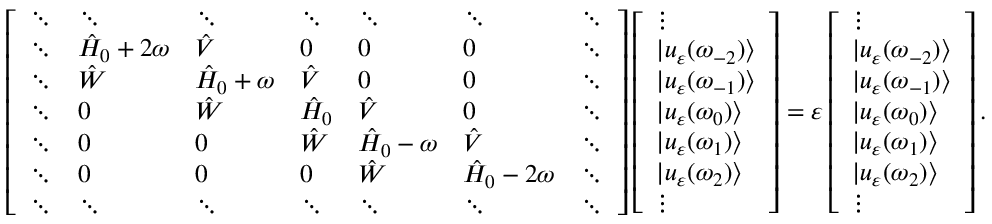<formula> <loc_0><loc_0><loc_500><loc_500>\left [ \begin{array} { l l l l l l l } { \ddots } & { \ddots } & { \ddots } & { \ddots } & { \ddots } & { \ddots } & { \ddots } \\ { \ddots } & { \hat { H } _ { 0 } + 2 \omega } & { \hat { V } } & { 0 } & { 0 } & { 0 } & { \ddots } \\ { \ddots } & { \hat { W } } & { \hat { H } _ { 0 } + \omega } & { \hat { V } } & { 0 } & { 0 } & { \ddots } \\ { \ddots } & { 0 } & { \hat { W } } & { \hat { H } _ { 0 } } & { \hat { V } } & { 0 } & { \ddots } \\ { \ddots } & { 0 } & { 0 } & { \hat { W } } & { \hat { H } _ { 0 } - \omega } & { \hat { V } } & { \ddots } \\ { \ddots } & { 0 } & { 0 } & { 0 } & { \hat { W } } & { \hat { H } _ { 0 } - 2 \omega } & { \ddots } \\ { \ddots } & { \ddots } & { \ddots } & { \ddots } & { \ddots } & { \ddots } & { \ddots } \end{array} \right ] \left [ \begin{array} { l } { \vdots } \\ { | u _ { \varepsilon } ( \omega _ { - 2 } ) \rangle } \\ { | u _ { \varepsilon } ( \omega _ { - 1 } ) \rangle } \\ { | u _ { \varepsilon } ( \omega _ { 0 } ) \rangle } \\ { | u _ { \varepsilon } ( \omega _ { 1 } ) \rangle } \\ { | u _ { \varepsilon } ( \omega _ { 2 } ) \rangle } \\ { \vdots } \end{array} \right ] = \varepsilon \left [ \begin{array} { l } { \vdots } \\ { | u _ { \varepsilon } ( \omega _ { - 2 } ) \rangle } \\ { | u _ { \varepsilon } ( \omega _ { - 1 } ) \rangle } \\ { | u _ { \varepsilon } ( \omega _ { 0 } ) \rangle } \\ { | u _ { \varepsilon } ( \omega _ { 1 } ) \rangle } \\ { | u _ { \varepsilon } ( \omega _ { 2 } ) \rangle } \\ { \vdots } \end{array} \right ] .</formula> 